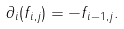<formula> <loc_0><loc_0><loc_500><loc_500>\partial _ { i } ( f _ { i , j } ) = - f _ { i - 1 , j } .</formula> 